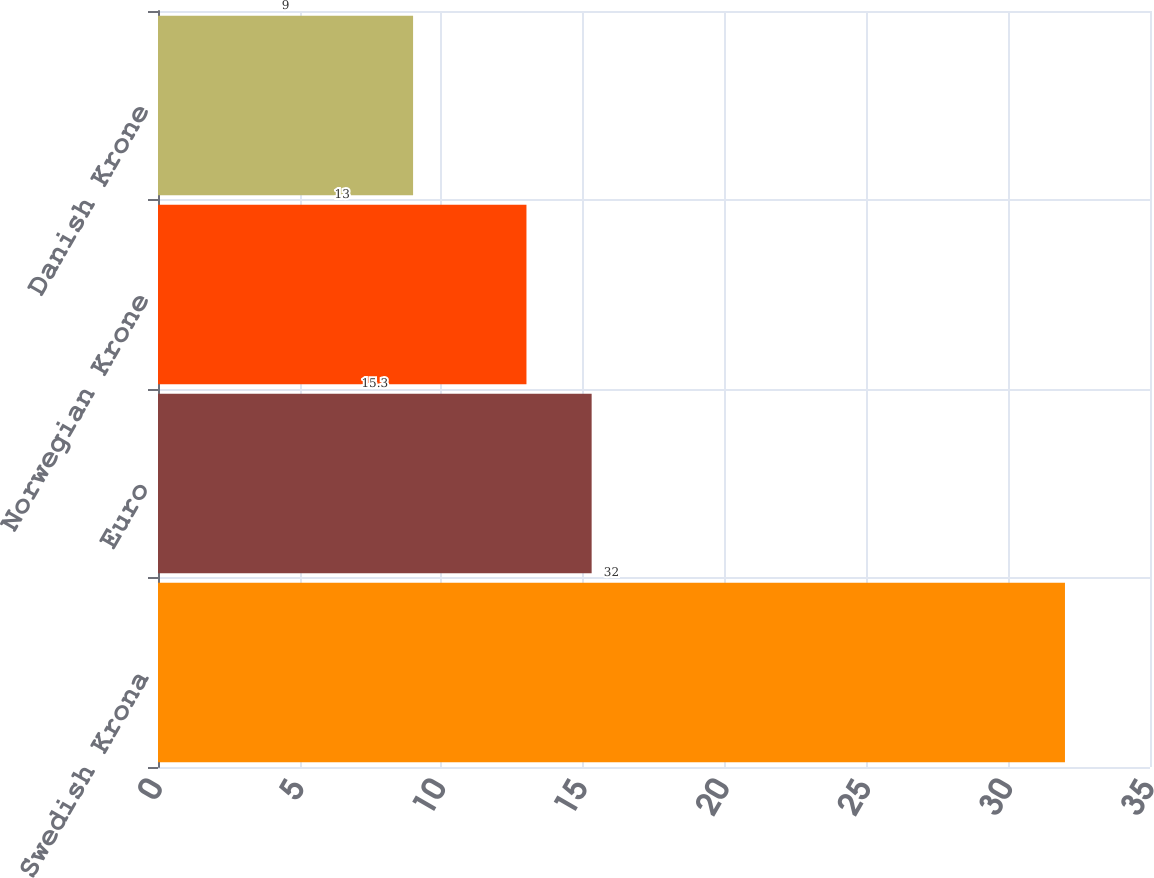Convert chart to OTSL. <chart><loc_0><loc_0><loc_500><loc_500><bar_chart><fcel>Swedish Krona<fcel>Euro<fcel>Norwegian Krone<fcel>Danish Krone<nl><fcel>32<fcel>15.3<fcel>13<fcel>9<nl></chart> 